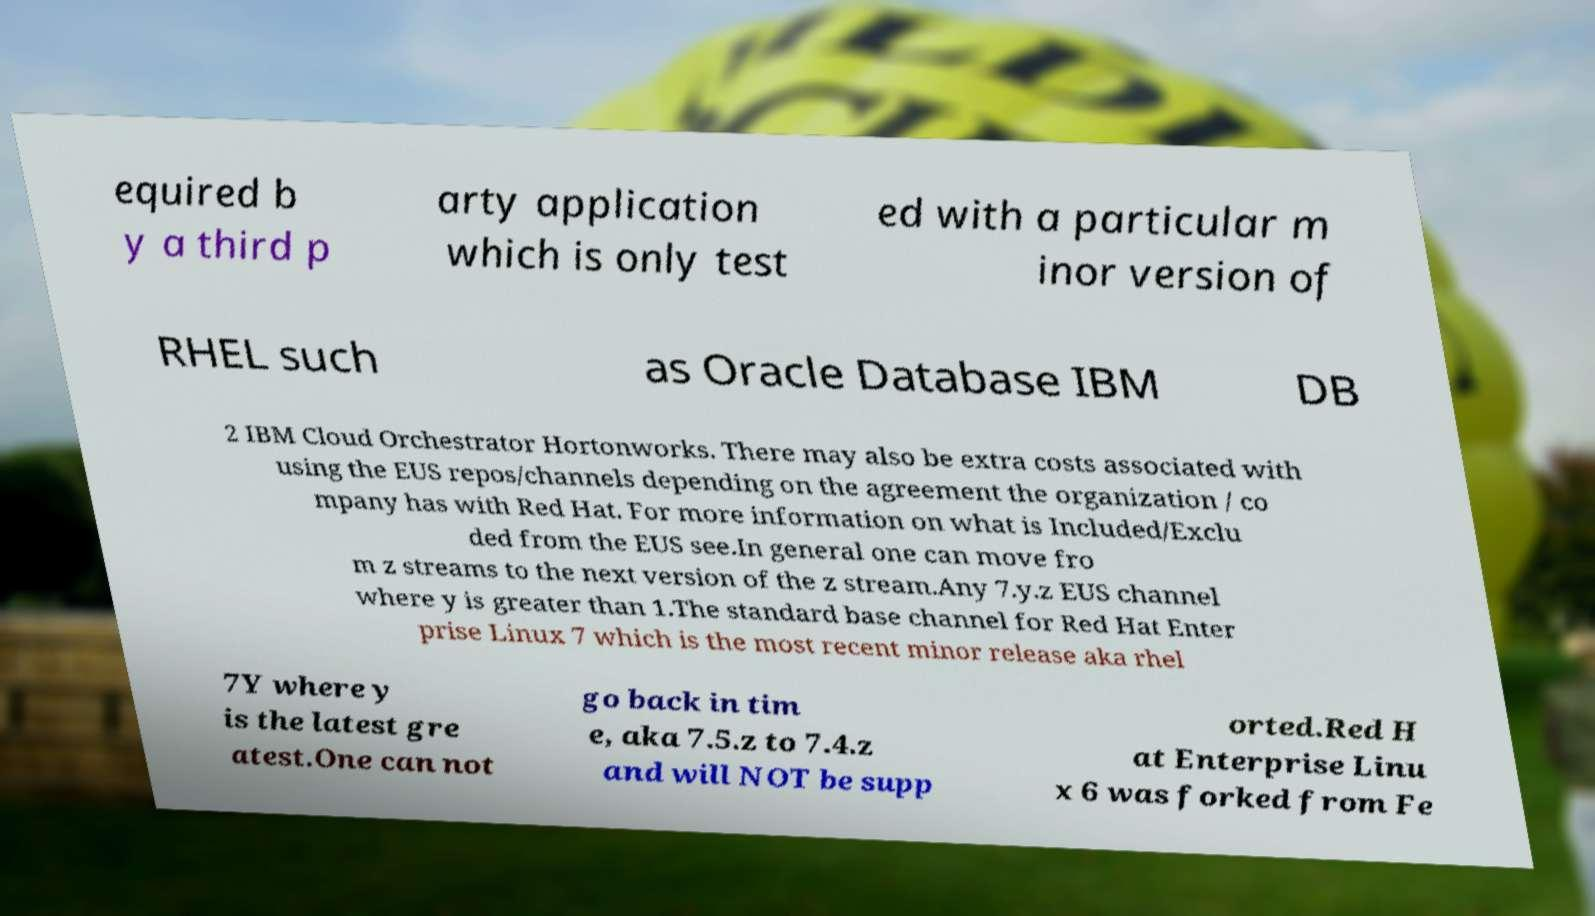Can you read and provide the text displayed in the image?This photo seems to have some interesting text. Can you extract and type it out for me? equired b y a third p arty application which is only test ed with a particular m inor version of RHEL such as Oracle Database IBM DB 2 IBM Cloud Orchestrator Hortonworks. There may also be extra costs associated with using the EUS repos/channels depending on the agreement the organization / co mpany has with Red Hat. For more information on what is Included/Exclu ded from the EUS see.In general one can move fro m z streams to the next version of the z stream.Any 7.y.z EUS channel where y is greater than 1.The standard base channel for Red Hat Enter prise Linux 7 which is the most recent minor release aka rhel 7Y where y is the latest gre atest.One can not go back in tim e, aka 7.5.z to 7.4.z and will NOT be supp orted.Red H at Enterprise Linu x 6 was forked from Fe 